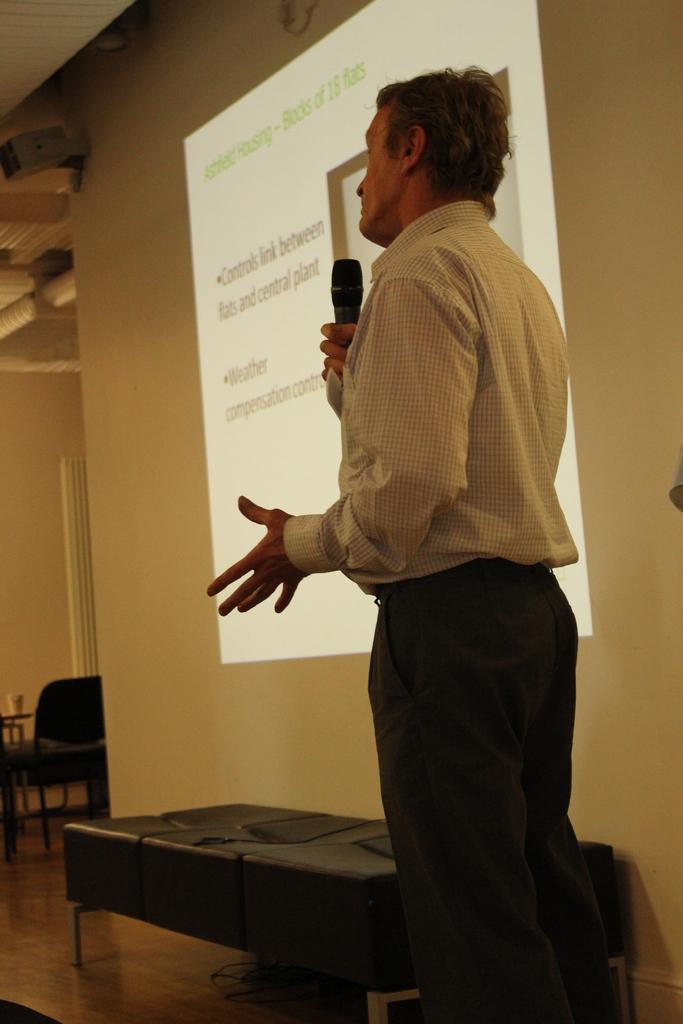Could you give a brief overview of what you see in this image? In this image there is a man standing and holding a microphone in his hand and in back ground there is table, chair , glass , wall ,screen. 